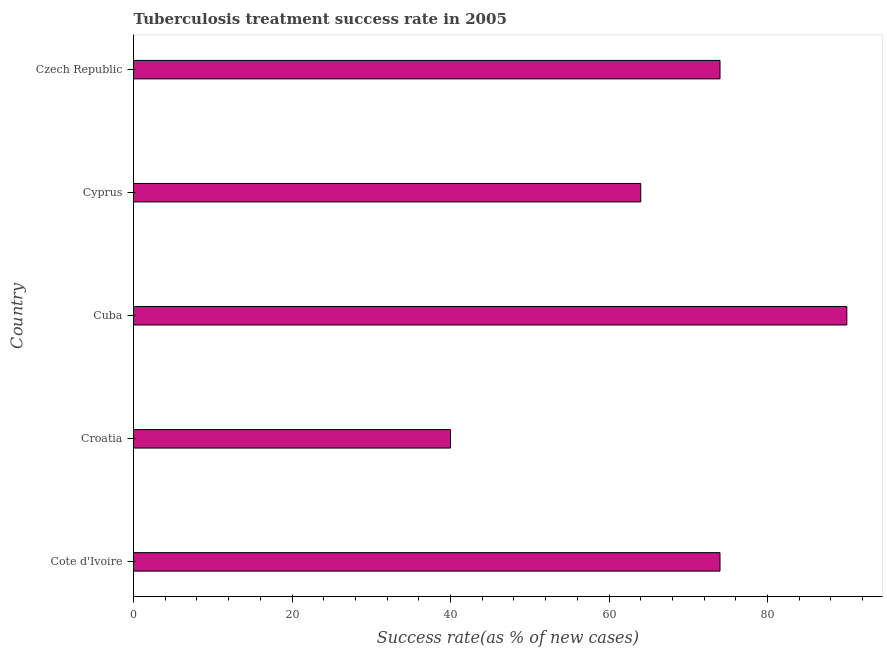What is the title of the graph?
Your response must be concise. Tuberculosis treatment success rate in 2005. What is the label or title of the X-axis?
Make the answer very short. Success rate(as % of new cases). Across all countries, what is the maximum tuberculosis treatment success rate?
Give a very brief answer. 90. In which country was the tuberculosis treatment success rate maximum?
Your answer should be very brief. Cuba. In which country was the tuberculosis treatment success rate minimum?
Your answer should be very brief. Croatia. What is the sum of the tuberculosis treatment success rate?
Make the answer very short. 342. What is the average tuberculosis treatment success rate per country?
Offer a terse response. 68. What is the median tuberculosis treatment success rate?
Your answer should be very brief. 74. In how many countries, is the tuberculosis treatment success rate greater than 68 %?
Your response must be concise. 3. What is the ratio of the tuberculosis treatment success rate in Croatia to that in Czech Republic?
Your answer should be very brief. 0.54. Is the difference between the tuberculosis treatment success rate in Cote d'Ivoire and Cyprus greater than the difference between any two countries?
Provide a succinct answer. No. What is the difference between the highest and the second highest tuberculosis treatment success rate?
Offer a very short reply. 16. Is the sum of the tuberculosis treatment success rate in Cote d'Ivoire and Croatia greater than the maximum tuberculosis treatment success rate across all countries?
Offer a terse response. Yes. How many bars are there?
Give a very brief answer. 5. How many countries are there in the graph?
Ensure brevity in your answer.  5. What is the difference between two consecutive major ticks on the X-axis?
Make the answer very short. 20. What is the Success rate(as % of new cases) in Cote d'Ivoire?
Make the answer very short. 74. What is the Success rate(as % of new cases) of Cuba?
Offer a terse response. 90. What is the Success rate(as % of new cases) in Cyprus?
Provide a succinct answer. 64. What is the Success rate(as % of new cases) in Czech Republic?
Offer a terse response. 74. What is the difference between the Success rate(as % of new cases) in Cote d'Ivoire and Cyprus?
Give a very brief answer. 10. What is the difference between the Success rate(as % of new cases) in Cote d'Ivoire and Czech Republic?
Your response must be concise. 0. What is the difference between the Success rate(as % of new cases) in Croatia and Czech Republic?
Your response must be concise. -34. What is the difference between the Success rate(as % of new cases) in Cuba and Czech Republic?
Keep it short and to the point. 16. What is the difference between the Success rate(as % of new cases) in Cyprus and Czech Republic?
Give a very brief answer. -10. What is the ratio of the Success rate(as % of new cases) in Cote d'Ivoire to that in Croatia?
Provide a short and direct response. 1.85. What is the ratio of the Success rate(as % of new cases) in Cote d'Ivoire to that in Cuba?
Your response must be concise. 0.82. What is the ratio of the Success rate(as % of new cases) in Cote d'Ivoire to that in Cyprus?
Your response must be concise. 1.16. What is the ratio of the Success rate(as % of new cases) in Croatia to that in Cuba?
Ensure brevity in your answer.  0.44. What is the ratio of the Success rate(as % of new cases) in Croatia to that in Cyprus?
Offer a terse response. 0.62. What is the ratio of the Success rate(as % of new cases) in Croatia to that in Czech Republic?
Ensure brevity in your answer.  0.54. What is the ratio of the Success rate(as % of new cases) in Cuba to that in Cyprus?
Provide a short and direct response. 1.41. What is the ratio of the Success rate(as % of new cases) in Cuba to that in Czech Republic?
Give a very brief answer. 1.22. What is the ratio of the Success rate(as % of new cases) in Cyprus to that in Czech Republic?
Your answer should be compact. 0.86. 